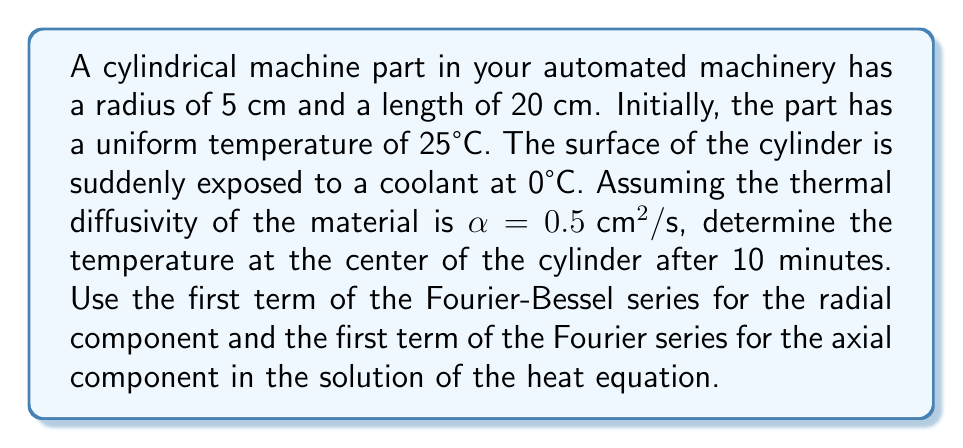Solve this math problem. To solve this problem, we'll use the heat equation in cylindrical coordinates and apply separation of variables. The solution will be in the form of a Fourier-Bessel series.

1) The heat equation in cylindrical coordinates (assuming axial symmetry):

   $$\frac{\partial T}{\partial t} = \alpha \left(\frac{\partial^2 T}{\partial r^2} + \frac{1}{r}\frac{\partial T}{\partial r} + \frac{\partial^2 T}{\partial z^2}\right)$$

2) The general solution, considering only the first terms:

   $$T(r,z,t) = (T_0 - T_s)J_0\left(\frac{\beta_1 r}{R}\right)\cos\left(\frac{\pi z}{L}\right)e^{-\alpha t(\frac{\beta_1^2}{R^2} + \frac{\pi^2}{L^2})} + T_s$$

   Where:
   - $T_0$ is the initial temperature (25°C)
   - $T_s$ is the surface temperature (0°C)
   - $J_0$ is the Bessel function of the first kind of order zero
   - $\beta_1$ is the first root of $J_0(x) = 0$, approximately 2.4048
   - $R$ is the radius (5 cm)
   - $L$ is the length (20 cm)

3) At the center, $r = 0$ and $z = L/2$:

   $$T(0,L/2,t) = (T_0 - T_s)J_0(0)\cos\left(\frac{\pi}{2}\right)e^{-\alpha t(\frac{\beta_1^2}{R^2} + \frac{\pi^2}{L^2})} + T_s$$

4) Substitute the values:
   - $J_0(0) = 1$
   - $\cos(\pi/2) = 0$
   - $t = 10 \text{ min} = 600 \text{ s}$
   - $\alpha = 0.5 \text{ cm}^2/\text{s}$
   - $R = 5 \text{ cm}$
   - $L = 20 \text{ cm}$

5) Calculate:

   $$T(0,L/2,600) = 25 \cdot 1 \cdot 0 \cdot e^{-0.5 \cdot 600(\frac{2.4048^2}{5^2} + \frac{\pi^2}{20^2})} + 0 = 0°C$$

Therefore, after 10 minutes, the temperature at the center of the cylinder will be approximately 0°C.
Answer: 0°C 